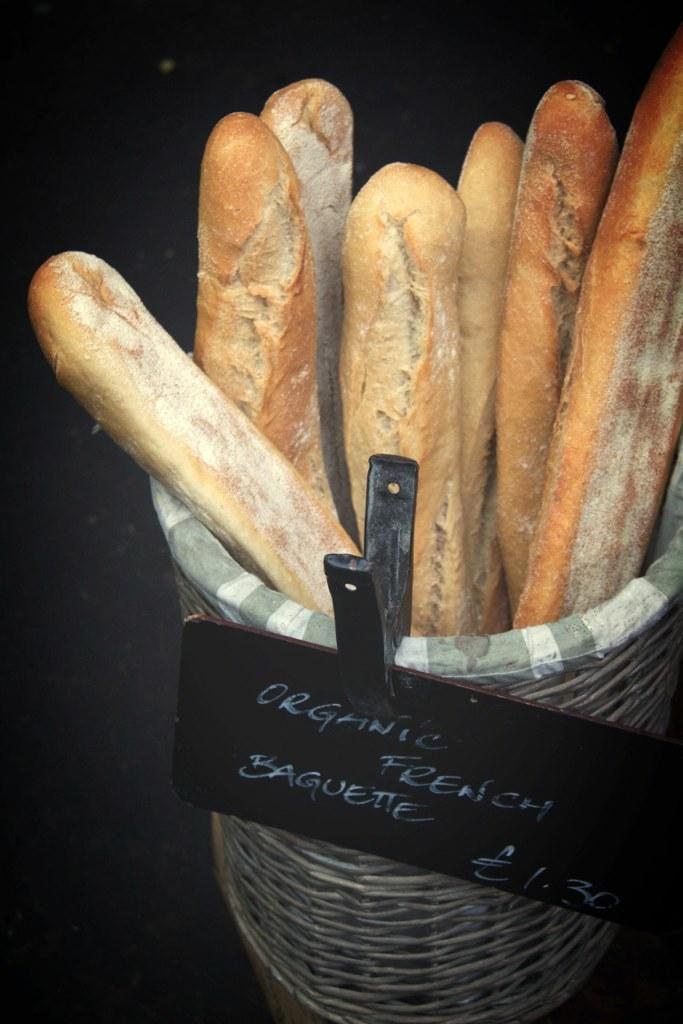How would you summarize this image in a sentence or two? There is a basket with a name board clipped on that. Inside the basket there are breads. 